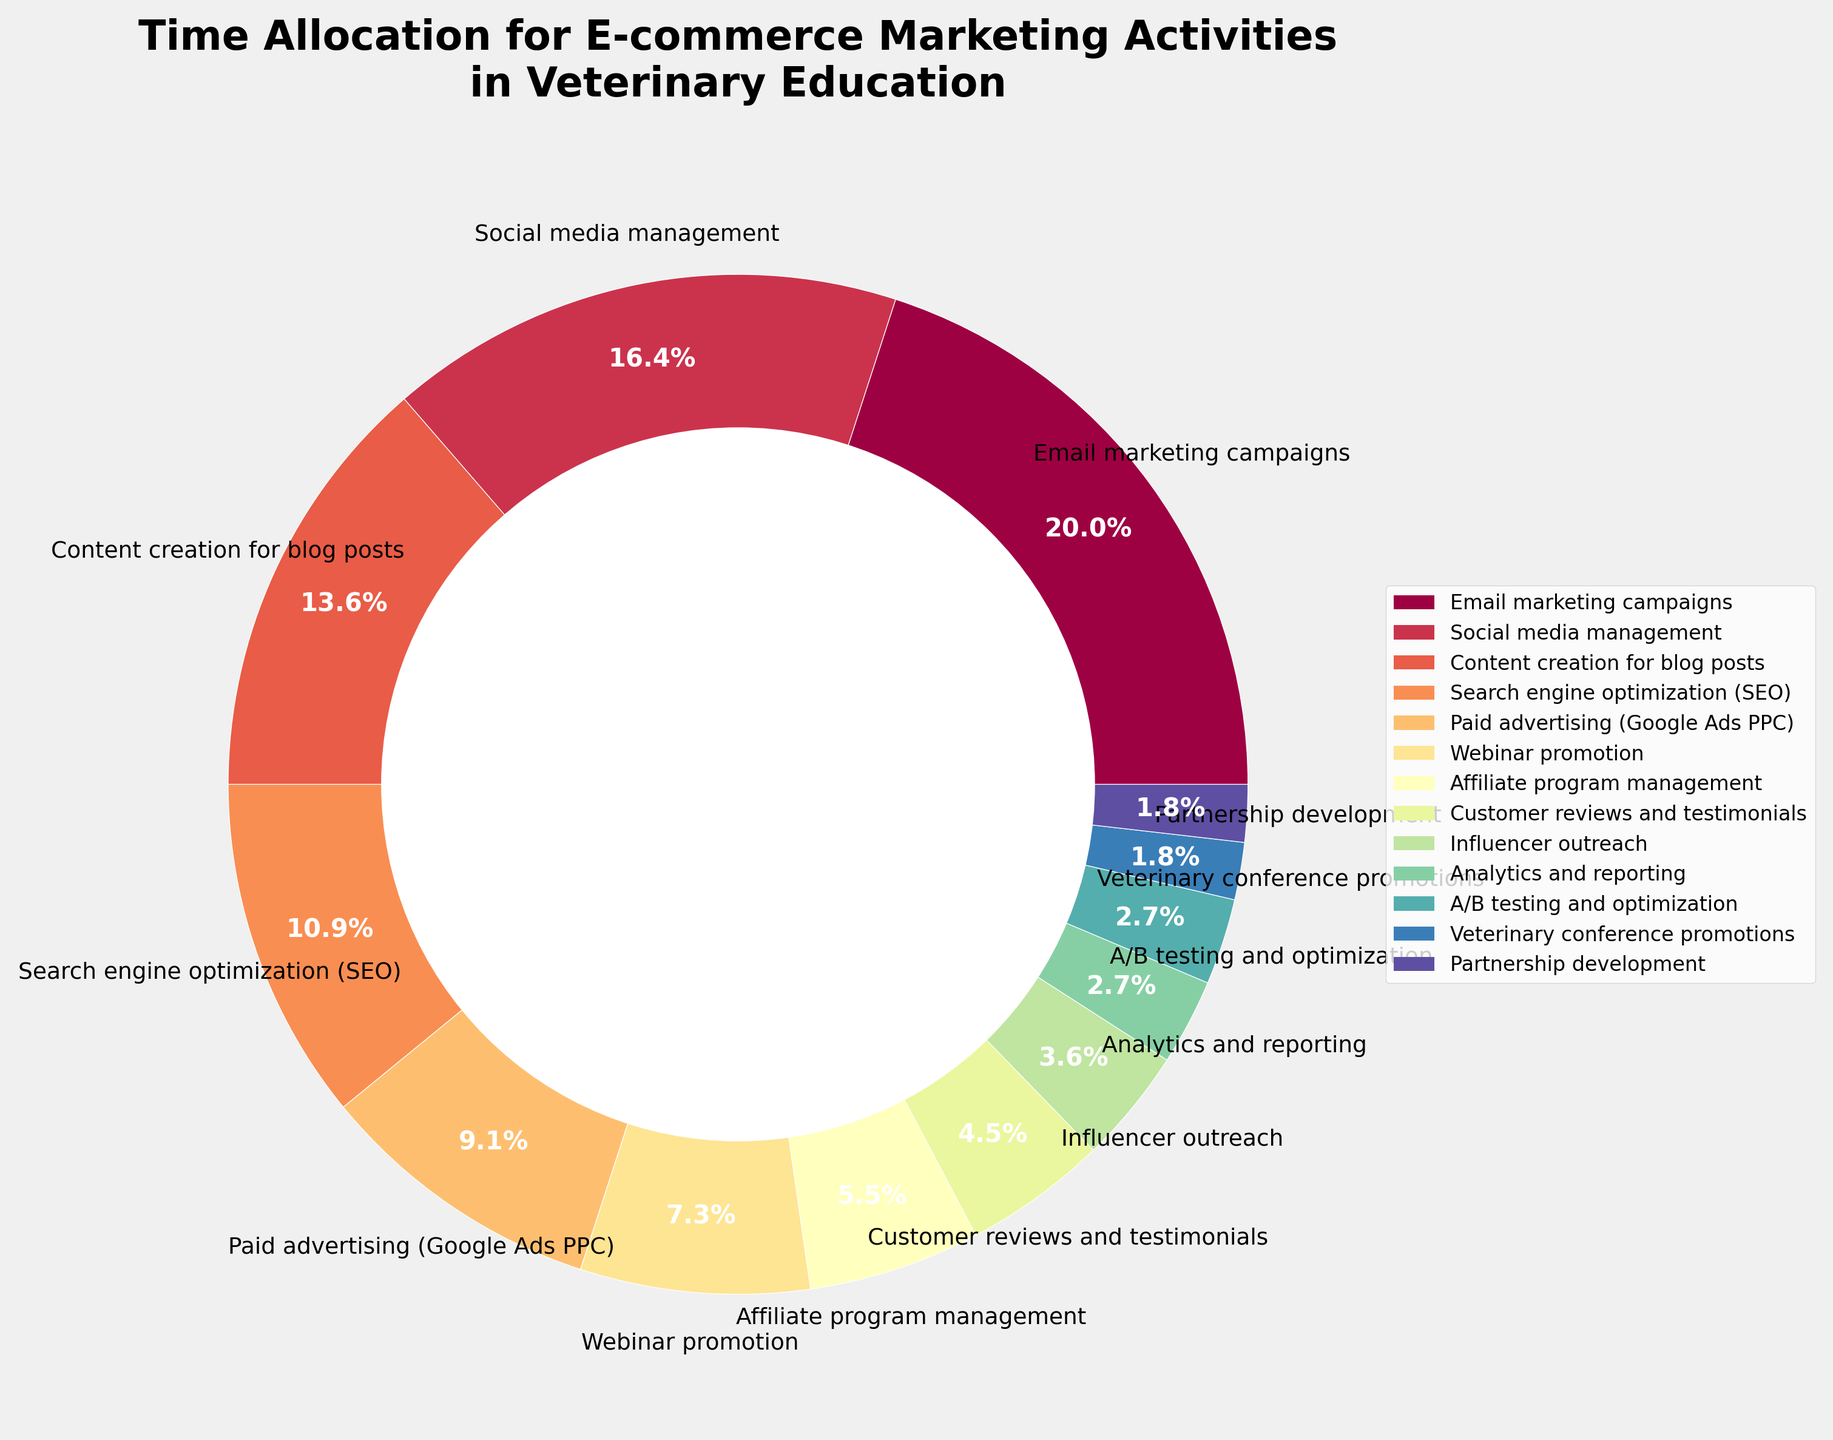What activity takes up the largest percentage of time? The largest percentage in the pie chart corresponds to the activity with the highest value. In this case, 'Email marketing campaigns' has a percentage of 22%, which is the highest among all activities.
Answer: Email marketing campaigns Which two activities together make up 30% of the time allocation? To find two activities that sum to 30%, we look at the percentages. 'Social media management' is 18% and 'Search engine optimization (SEO)' is 12%. Adding these two gives 18% + 12% = 30%.
Answer: Social media management and Search engine optimization (SEO) How much more time is allocated to Paid advertising (Google Ads PPC) compared to Influencer outreach? 'Paid advertising (Google Ads PPC)' is 10% and 'Influencer outreach' is 4%. Subtracting these gives 10% - 4% = 6%.
Answer: 6% Which activity is allocated the least amount of time? The pie chart's smallest segment corresponds to the activity with the lowest percentage. In this case, 'Veterinary conference promotions' and 'Partnership development' are both at 2%, the smallest in the chart.
Answer: Veterinary conference promotions and Partnership development If the time allocation for Content creation for blog posts were halved, what would its new percentage be? The current percentage for 'Content creation for blog posts' is 15%. Halving this value is calculated as 15% / 2 = 7.5%.
Answer: 7.5% What is the combined percentage of activities allocated 5% or less? Adding the percentages of 'Customer reviews and testimonials' (5%), 'Influencer outreach' (4%), 'Analytics and reporting' (3%), 'A/B testing and optimization' (3%), 'Veterinary conference promotions' (2%), and 'Partnership development' (2%) results in 5% + 4% + 3% + 3% + 2% + 2% = 19%.
Answer: 19% Which color corresponds to Search engine optimization (SEO) in the pie chart? The pie chart uses a color spectrum, and 'Search engine optimization (SEO)' is labeled with a specific color. Based on the figure, identify this color visually.
Answer: (Requires specific color from the chart, typically a descriptor like "green" or "purple") Are there more activities allocated above or below 5%? Counting the activities with percentages above 5% and below 5%. Above 5%: 6 ('Email marketing campaigns', 'Social media management', 'Content creation for blog posts', 'Search engine optimization', 'Paid advertising', 'Webinar promotion'). Below 5%: 6 ('Affiliate program management', 'Customer reviews and testimonials', 'Influencer outreach', 'Analytics and reporting', 'A/B testing and optimization', 'Veterinary conference promotions', 'Partnership development').
Answer: Equal Which activity is allocated exactly 10% of the time? Looking at the pie chart, identify the activity corresponding to the 10% slice. 'Paid advertising (Google Ads PPC)' is labeled as 10%.
Answer: Paid advertising (Google Ads PPC) What percentage of time is allocated to activities related to content (Content creation for blog posts, Customer reviews and testimonials)? Adding 'Content creation for blog posts' 15% and 'Customer reviews and testimonials' 5% gives 15% + 5% = 20%.
Answer: 20% 